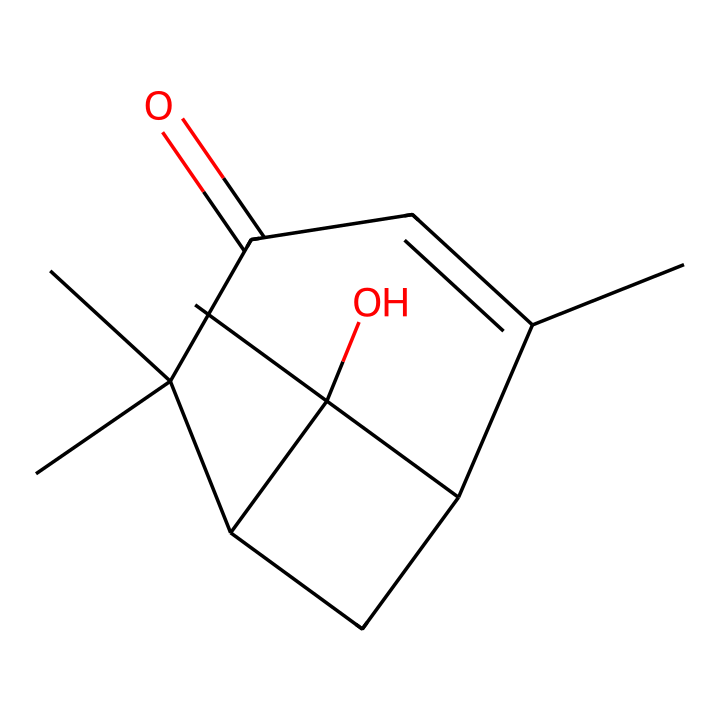What is the main functional group present in this chemical? Analyzing the SMILES structure, particularly the portion that includes C(=O), we see a carbonyl group (C=O). Coupled with the nitrogen atom typically found in imides, we identify the functional group as an imide.
Answer: imide How many carbon atoms are there in the structure? By breaking down the SMILES representation and counting each 'C', we find a total of 12 carbon atoms.
Answer: 12 What type of isomerism can this imide exhibit? Given the presence of multiple chiral centers shown by the configuration around some carbon atoms, this imide can exhibit stereoisomerism due to its asymmetric carbon structures.
Answer: stereoisomerism Are there any heteroatoms in this compound? Inspection of the SMILES reveals a nitrogen atom, which is indeed a heteroatom, indicating the compound's potential properties related to its imide nature.
Answer: nitrogen What type of bonding can be inferred from the presence of the C(=O) group? The carbonyl group indicates the presence of polar covalent bonds since the oxygen is more electronegative than carbon, affecting the compound's reactivity and interactions.
Answer: polar covalent Is this compound likely to be hydrophilic or hydrophobic? The presence of an imide functional group, particularly with the carbonyl, suggests it can form hydrogen bonds, providing it a degree of hydrophilicity; however, the overall structure may lean towards hydrophobic due to the large carbon framework.
Answer: hydrophilic 